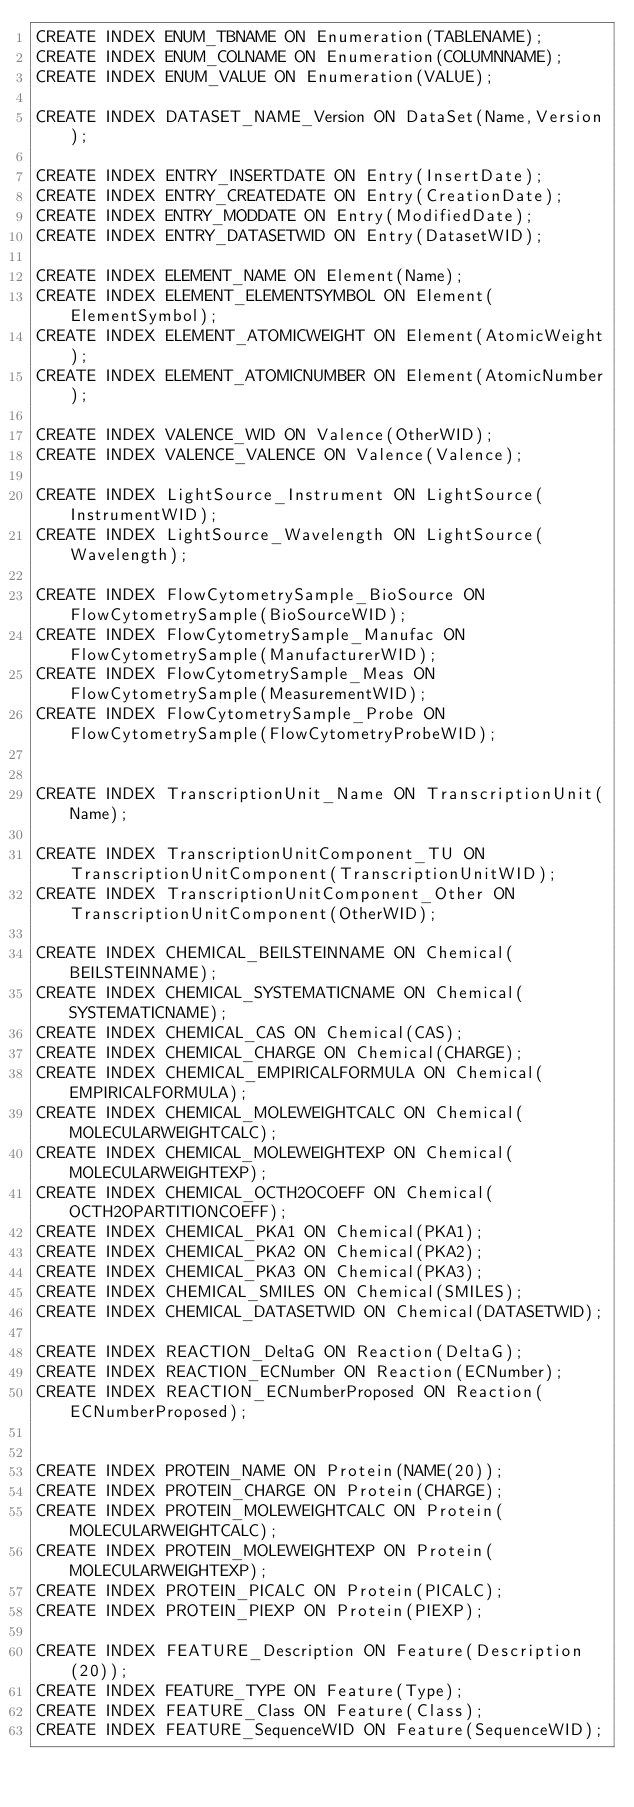Convert code to text. <code><loc_0><loc_0><loc_500><loc_500><_SQL_>CREATE INDEX ENUM_TBNAME ON Enumeration(TABLENAME);
CREATE INDEX ENUM_COLNAME ON Enumeration(COLUMNNAME);
CREATE INDEX ENUM_VALUE ON Enumeration(VALUE);

CREATE INDEX DATASET_NAME_Version ON DataSet(Name,Version);

CREATE INDEX ENTRY_INSERTDATE ON Entry(InsertDate);
CREATE INDEX ENTRY_CREATEDATE ON Entry(CreationDate);
CREATE INDEX ENTRY_MODDATE ON Entry(ModifiedDate);
CREATE INDEX ENTRY_DATASETWID ON Entry(DatasetWID);

CREATE INDEX ELEMENT_NAME ON Element(Name);
CREATE INDEX ELEMENT_ELEMENTSYMBOL ON Element(ElementSymbol);
CREATE INDEX ELEMENT_ATOMICWEIGHT ON Element(AtomicWeight);
CREATE INDEX ELEMENT_ATOMICNUMBER ON Element(AtomicNumber);

CREATE INDEX VALENCE_WID ON Valence(OtherWID);
CREATE INDEX VALENCE_VALENCE ON Valence(Valence);

CREATE INDEX LightSource_Instrument ON LightSource(InstrumentWID);
CREATE INDEX LightSource_Wavelength ON LightSource(Wavelength);

CREATE INDEX FlowCytometrySample_BioSource ON FlowCytometrySample(BioSourceWID);
CREATE INDEX FlowCytometrySample_Manufac ON FlowCytometrySample(ManufacturerWID);
CREATE INDEX FlowCytometrySample_Meas ON FlowCytometrySample(MeasurementWID);
CREATE INDEX FlowCytometrySample_Probe ON FlowCytometrySample(FlowCytometryProbeWID);


CREATE INDEX TranscriptionUnit_Name ON TranscriptionUnit(Name);

CREATE INDEX TranscriptionUnitComponent_TU ON TranscriptionUnitComponent(TranscriptionUnitWID);
CREATE INDEX TranscriptionUnitComponent_Other ON TranscriptionUnitComponent(OtherWID);

CREATE INDEX CHEMICAL_BEILSTEINNAME ON Chemical(BEILSTEINNAME);
CREATE INDEX CHEMICAL_SYSTEMATICNAME ON Chemical(SYSTEMATICNAME);
CREATE INDEX CHEMICAL_CAS ON Chemical(CAS);
CREATE INDEX CHEMICAL_CHARGE ON Chemical(CHARGE);
CREATE INDEX CHEMICAL_EMPIRICALFORMULA ON Chemical(EMPIRICALFORMULA);
CREATE INDEX CHEMICAL_MOLEWEIGHTCALC ON Chemical(MOLECULARWEIGHTCALC);
CREATE INDEX CHEMICAL_MOLEWEIGHTEXP ON Chemical(MOLECULARWEIGHTEXP);
CREATE INDEX CHEMICAL_OCTH2OCOEFF ON Chemical(OCTH2OPARTITIONCOEFF);
CREATE INDEX CHEMICAL_PKA1 ON Chemical(PKA1);
CREATE INDEX CHEMICAL_PKA2 ON Chemical(PKA2);
CREATE INDEX CHEMICAL_PKA3 ON Chemical(PKA3);
CREATE INDEX CHEMICAL_SMILES ON Chemical(SMILES);
CREATE INDEX CHEMICAL_DATASETWID ON Chemical(DATASETWID);

CREATE INDEX REACTION_DeltaG ON Reaction(DeltaG);
CREATE INDEX REACTION_ECNumber ON Reaction(ECNumber);
CREATE INDEX REACTION_ECNumberProposed ON Reaction(ECNumberProposed);


CREATE INDEX PROTEIN_NAME ON Protein(NAME(20));
CREATE INDEX PROTEIN_CHARGE ON Protein(CHARGE);
CREATE INDEX PROTEIN_MOLEWEIGHTCALC ON Protein(MOLECULARWEIGHTCALC);
CREATE INDEX PROTEIN_MOLEWEIGHTEXP ON Protein(MOLECULARWEIGHTEXP);
CREATE INDEX PROTEIN_PICALC ON Protein(PICALC);
CREATE INDEX PROTEIN_PIEXP ON Protein(PIEXP);

CREATE INDEX FEATURE_Description ON Feature(Description(20));
CREATE INDEX FEATURE_TYPE ON Feature(Type);
CREATE INDEX FEATURE_Class ON Feature(Class);
CREATE INDEX FEATURE_SequenceWID ON Feature(SequenceWID);</code> 